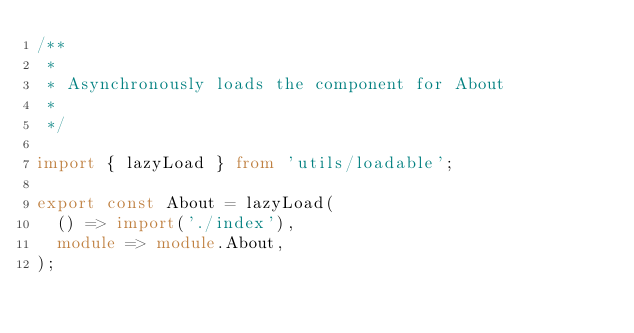Convert code to text. <code><loc_0><loc_0><loc_500><loc_500><_TypeScript_>/**
 *
 * Asynchronously loads the component for About
 *
 */

import { lazyLoad } from 'utils/loadable';

export const About = lazyLoad(
  () => import('./index'),
  module => module.About,
);
</code> 